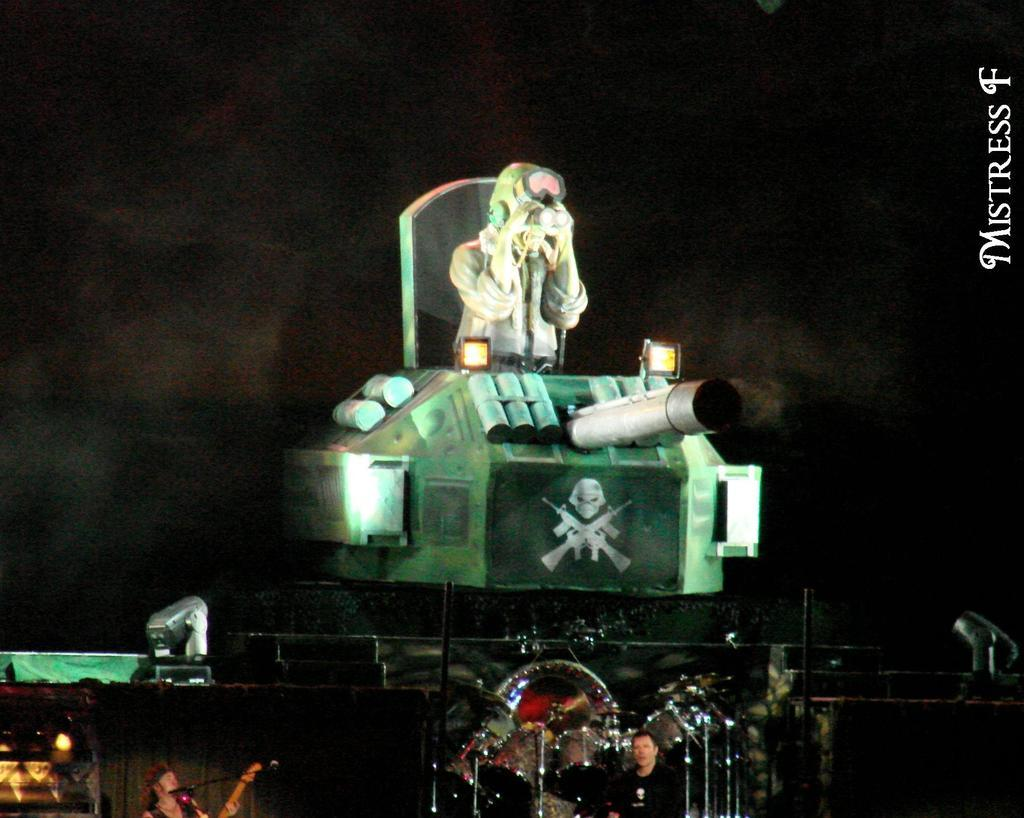How many people are in the image? There are three people in the image. What musical instruments can be seen in the image? There are drums and a guitar in the image. What objects are present in the image that might be used for communication or amplification? There is a microphone (mic) in the image. What type of sign is visible in the image? There is a danger sign in the image. What is the background of the image like? The background of the image is dark. How does the brain increase the size of the prison in the image? There is no brain, increase, or prison present in the image. 